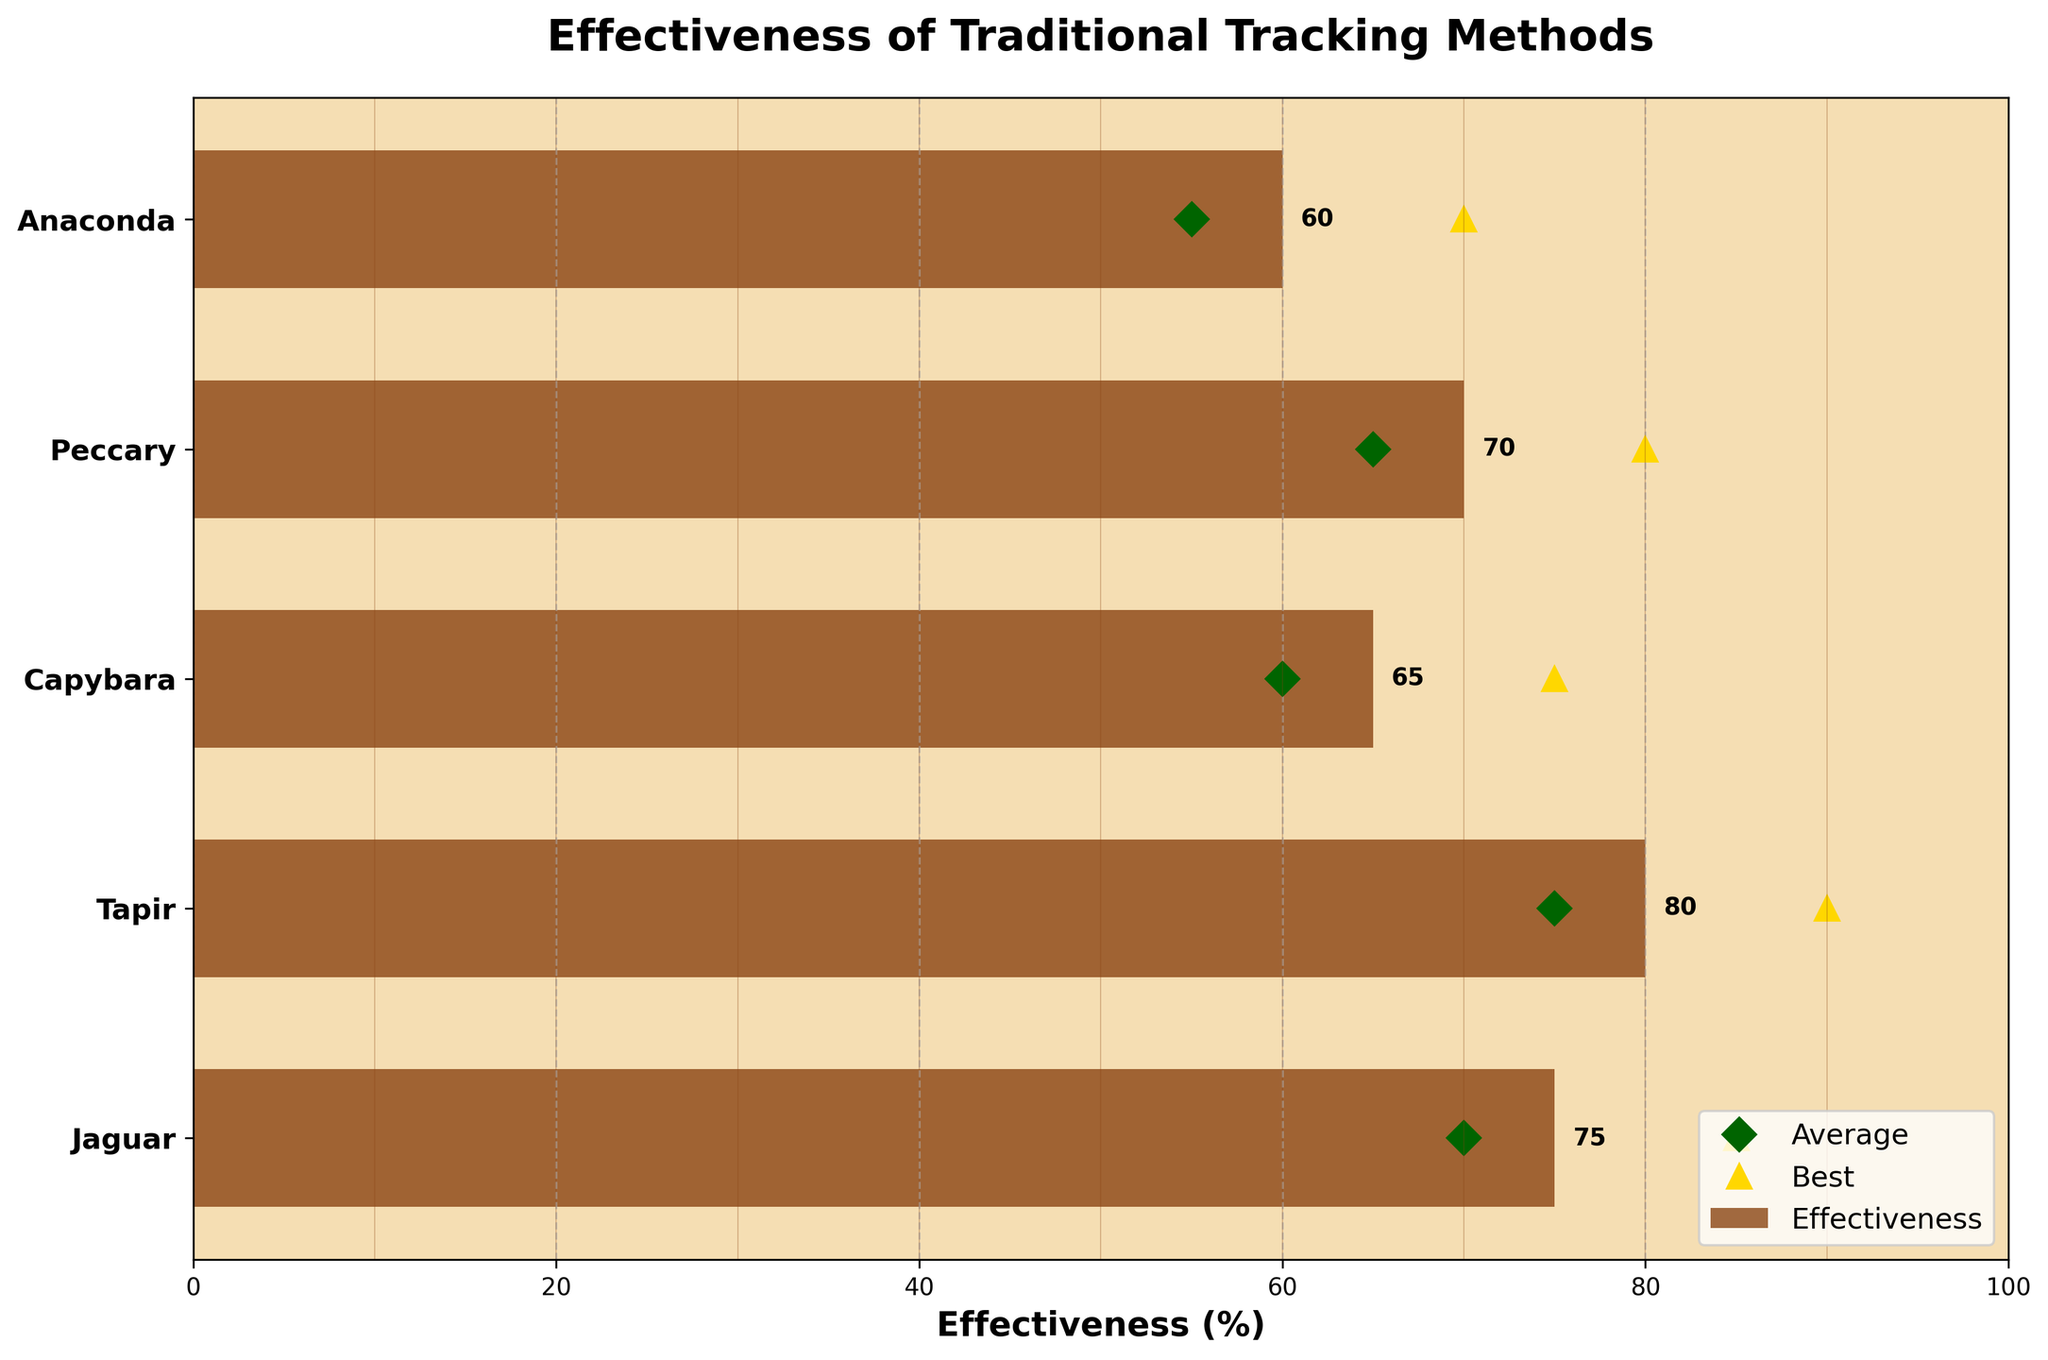What is the title of the figure? The title is located at the top of the figure. It reads "Effectiveness of Traditional Tracking Methods".
Answer: Effectiveness of Traditional Tracking Methods Which tracking method has the highest effectiveness percentage for Jaguars? Look directly at the bar corresponding to the Jaguar. The label at the end of the bar reads 75%.
Answer: Footprint tracking What is the average effectiveness percentage for tracking Tapirs? Look for the diamond symbol on the line corresponding to the Tapir and read the value. It shows 75%.
Answer: 75% Which animal's tracking method shows the lowest effectiveness percentage? Compare all the bars and find the smallest value. The bar for Anaconda shows the lowest value at 60%.
Answer: Anaconda What is the effectiveness percentage difference between Tapirs and Capybaras? Subtract the effectiveness percentage of Capybaras (65%) from that of Tapirs (80%). \(80 - 65 = 15 \).
Answer: 15% What are the average effectiveness percentages for each animal, listed from highest to lowest? Look for the diamond symbols and list their values in descending order: Tapir (75%), Jaguar (70%), Peccary (65%), Capybara (60%), Anaconda (55%).
Answer: 75%, 70%, 65%, 60%, 55% Which animal has the closest effectiveness percentage to its average effectiveness? Compare each bar's length to its corresponding diamond symbol and find the closest match. Jaguar has 75% effectiveness and 70% average effectiveness, with a difference of 5%.
Answer: Jaguar Which tracking method has the highest best effectiveness percentage? Look for the triangle symbols and identify the highest one. The highest triangle is at 90% for Tapirs.
Answer: Tapir Are any tracking methods equally effective according to the chart? Compare the bar lengths between all pairs of animals to check for any equal values. No two bars have the same length.
Answer: No By how much does the best effectiveness percentage of Tapirs exceed their average effectiveness percentage? Subtract the average percentage (75%) from the best percentage (90%). \( 90 - 75 = 15 \).
Answer: 15% 